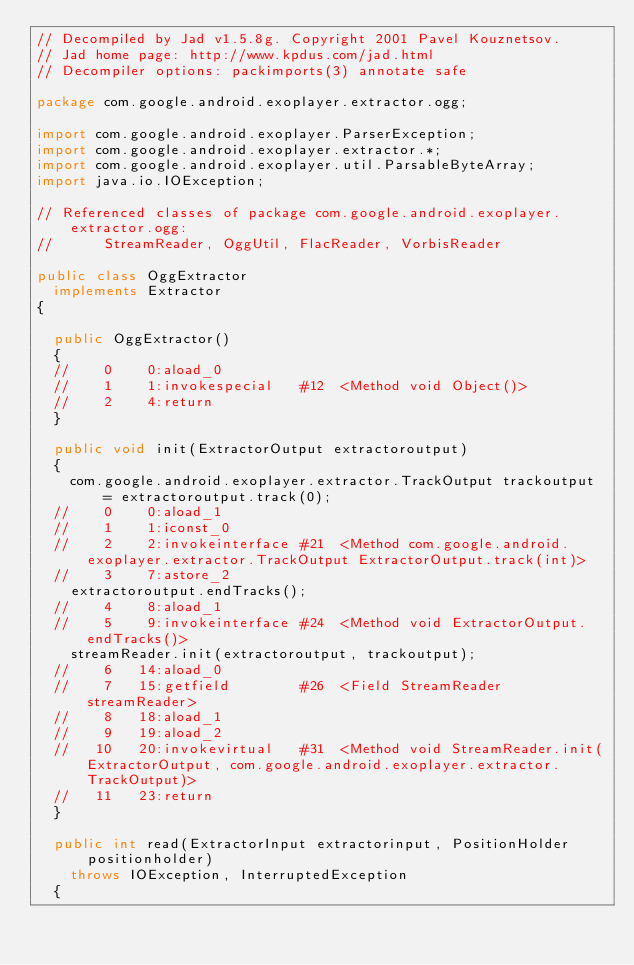<code> <loc_0><loc_0><loc_500><loc_500><_Java_>// Decompiled by Jad v1.5.8g. Copyright 2001 Pavel Kouznetsov.
// Jad home page: http://www.kpdus.com/jad.html
// Decompiler options: packimports(3) annotate safe 

package com.google.android.exoplayer.extractor.ogg;

import com.google.android.exoplayer.ParserException;
import com.google.android.exoplayer.extractor.*;
import com.google.android.exoplayer.util.ParsableByteArray;
import java.io.IOException;

// Referenced classes of package com.google.android.exoplayer.extractor.ogg:
//			StreamReader, OggUtil, FlacReader, VorbisReader

public class OggExtractor
	implements Extractor
{

	public OggExtractor()
	{
	//    0    0:aload_0         
	//    1    1:invokespecial   #12  <Method void Object()>
	//    2    4:return          
	}

	public void init(ExtractorOutput extractoroutput)
	{
		com.google.android.exoplayer.extractor.TrackOutput trackoutput = extractoroutput.track(0);
	//    0    0:aload_1         
	//    1    1:iconst_0        
	//    2    2:invokeinterface #21  <Method com.google.android.exoplayer.extractor.TrackOutput ExtractorOutput.track(int)>
	//    3    7:astore_2        
		extractoroutput.endTracks();
	//    4    8:aload_1         
	//    5    9:invokeinterface #24  <Method void ExtractorOutput.endTracks()>
		streamReader.init(extractoroutput, trackoutput);
	//    6   14:aload_0         
	//    7   15:getfield        #26  <Field StreamReader streamReader>
	//    8   18:aload_1         
	//    9   19:aload_2         
	//   10   20:invokevirtual   #31  <Method void StreamReader.init(ExtractorOutput, com.google.android.exoplayer.extractor.TrackOutput)>
	//   11   23:return          
	}

	public int read(ExtractorInput extractorinput, PositionHolder positionholder)
		throws IOException, InterruptedException
	{</code> 